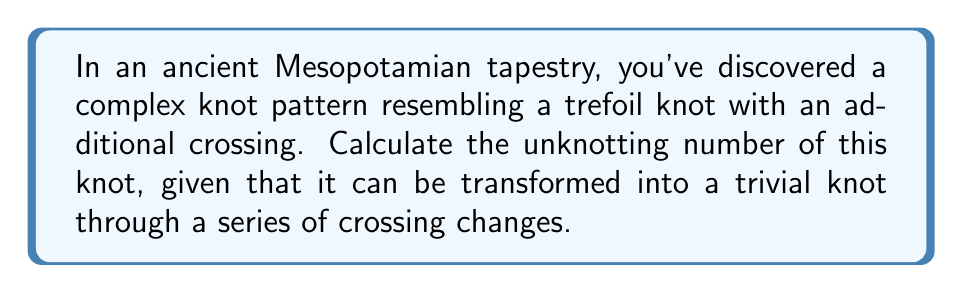Teach me how to tackle this problem. To calculate the unknotting number of this knot, we'll follow these steps:

1. Identify the knot type:
   The knot is described as a trefoil knot with an additional crossing. A standard trefoil knot has 3 crossings, so this knot has 4 crossings in total.

2. Recall the properties of a trefoil knot:
   - The unknotting number of a standard trefoil knot is 1.
   - The trefoil knot is the simplest non-trivial knot.

3. Analyze the additional crossing:
   - The extra crossing either increases the complexity of the knot or creates a reducible crossing.
   - In this case, since the knot can be transformed into a trivial knot, the additional crossing must be reducible.

4. Calculate the unknotting number:
   - The unknotting number is the minimum number of crossing changes required to obtain the trivial knot.
   - We need one crossing change to reduce the additional crossing.
   - We then need one more crossing change to unknot the remaining trefoil.

5. Express the unknotting number mathematically:
   Let $u(K)$ represent the unknotting number of our knot $K$.
   $$u(K) = u(\text{trefoil}) + u(\text{additional crossing}) = 1 + 1 = 2$$

Therefore, the unknotting number of the knot pattern observed in the ancient Mesopotamian tapestry is 2.
Answer: 2 